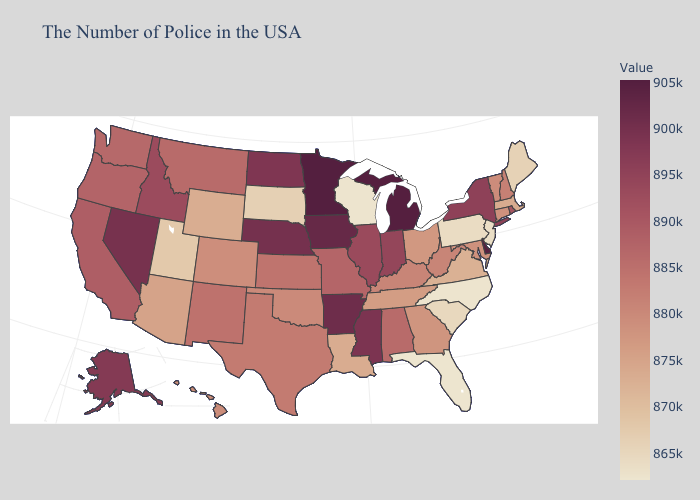Which states have the highest value in the USA?
Concise answer only. Minnesota. Does New Hampshire have the highest value in the Northeast?
Keep it brief. No. Among the states that border Virginia , does Maryland have the highest value?
Concise answer only. No. Is the legend a continuous bar?
Keep it brief. Yes. 